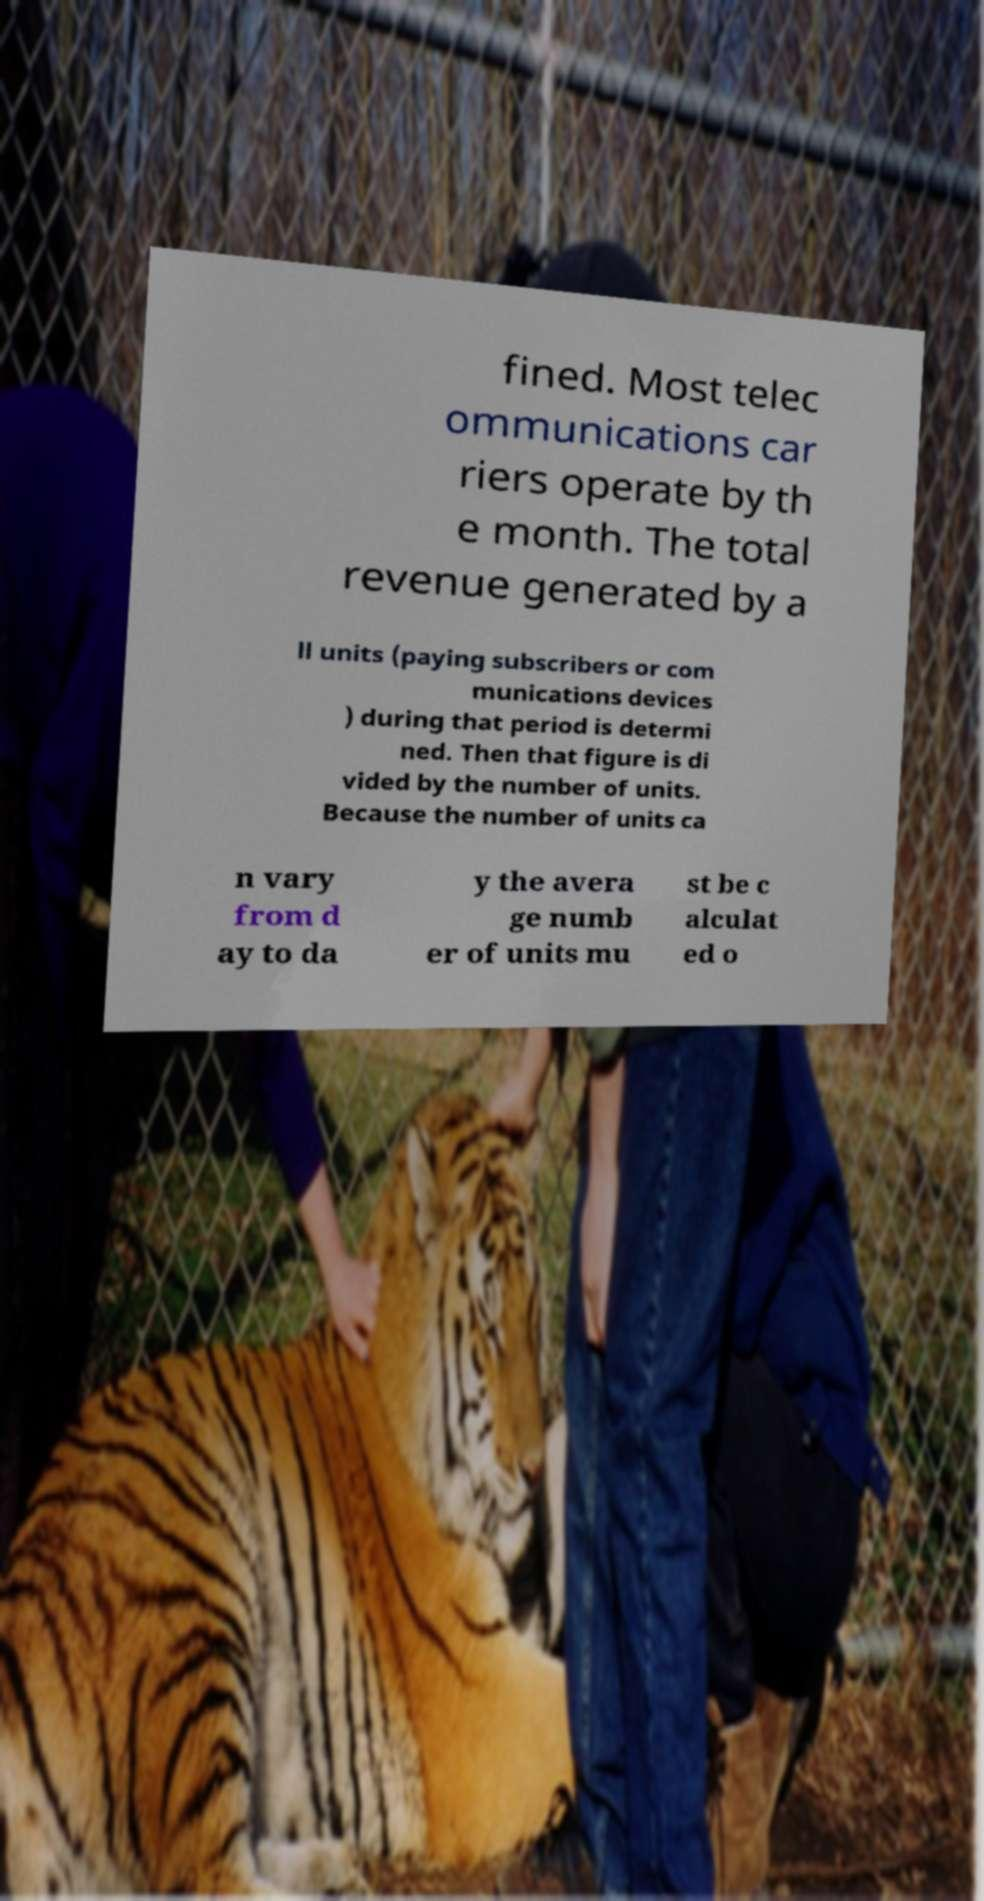Can you read and provide the text displayed in the image?This photo seems to have some interesting text. Can you extract and type it out for me? fined. Most telec ommunications car riers operate by th e month. The total revenue generated by a ll units (paying subscribers or com munications devices ) during that period is determi ned. Then that figure is di vided by the number of units. Because the number of units ca n vary from d ay to da y the avera ge numb er of units mu st be c alculat ed o 